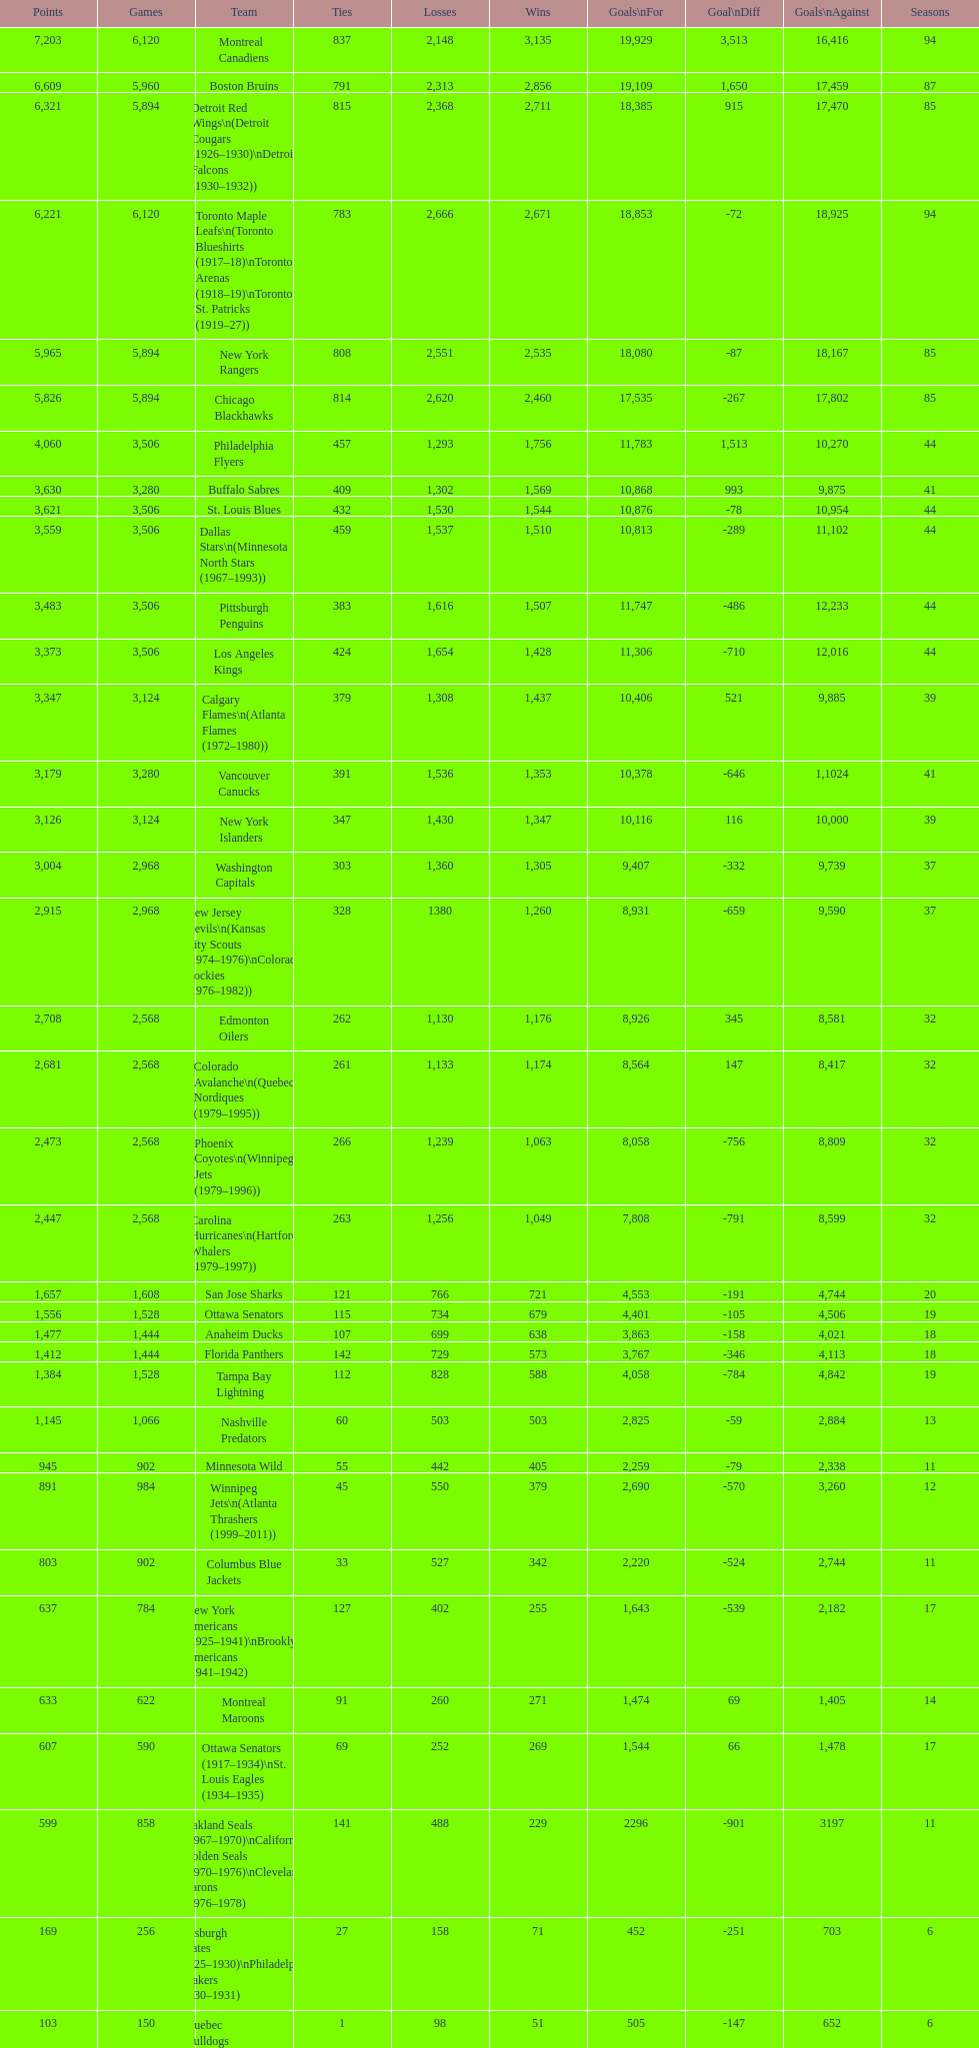Which team played the same amount of seasons as the canadiens? Toronto Maple Leafs. 